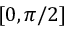<formula> <loc_0><loc_0><loc_500><loc_500>[ 0 , \pi / 2 ]</formula> 